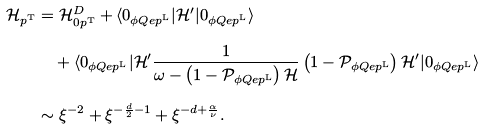Convert formula to latex. <formula><loc_0><loc_0><loc_500><loc_500>\mathcal { H } _ { p ^ { \text  T}} &=\mathcal{H}_{0p^{\text  T}}^{D} +\langle 0_{\phi Qep^{\text  L}}| \mathcal{H}^{\prime}|0_{\phi Qep^{\text  L}}\rangle \\ &\quad + \langle 0_{\phi Qep^{\text  L}}| \mathcal{H}^{\prime}\frac{1} { \omega-\left(1-\mathcal{P}_{\phi Qep^{\text  L} } \right ) \mathcal { H } } \left ( 1 - \mathcal { P } _ { \phi Q e p ^ { \text  L}}\right) \mathcal{H}^{\prime}|0_{\phi Qep^{\text  L}}\rangle \\ & \sim \xi^{-2} +\xi^{-\frac{d}{2}-1} +\xi^{-d+\frac{\alpha}{\nu}}.</formula> 